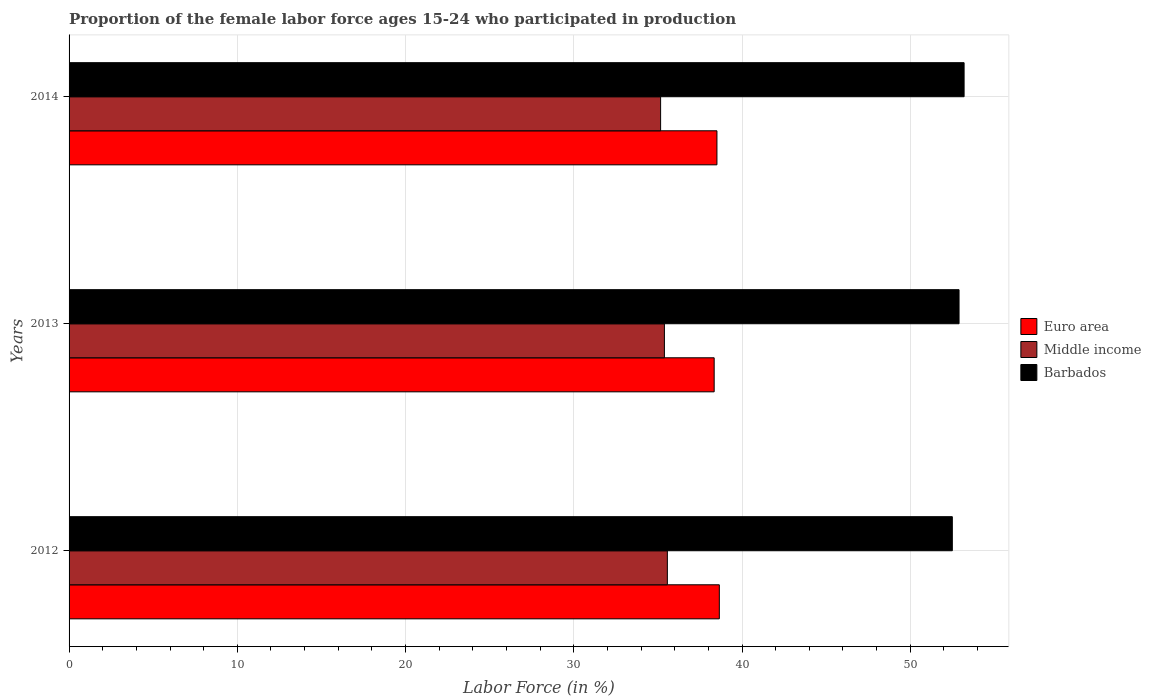How many different coloured bars are there?
Provide a succinct answer. 3. Are the number of bars per tick equal to the number of legend labels?
Offer a very short reply. Yes. Are the number of bars on each tick of the Y-axis equal?
Your response must be concise. Yes. In how many cases, is the number of bars for a given year not equal to the number of legend labels?
Your answer should be compact. 0. What is the proportion of the female labor force who participated in production in Euro area in 2014?
Provide a short and direct response. 38.51. Across all years, what is the maximum proportion of the female labor force who participated in production in Euro area?
Offer a very short reply. 38.65. Across all years, what is the minimum proportion of the female labor force who participated in production in Middle income?
Your answer should be very brief. 35.16. In which year was the proportion of the female labor force who participated in production in Middle income maximum?
Your answer should be very brief. 2012. What is the total proportion of the female labor force who participated in production in Euro area in the graph?
Provide a short and direct response. 115.5. What is the difference between the proportion of the female labor force who participated in production in Barbados in 2013 and that in 2014?
Your answer should be very brief. -0.3. What is the difference between the proportion of the female labor force who participated in production in Middle income in 2014 and the proportion of the female labor force who participated in production in Euro area in 2012?
Your answer should be very brief. -3.49. What is the average proportion of the female labor force who participated in production in Euro area per year?
Keep it short and to the point. 38.5. In the year 2012, what is the difference between the proportion of the female labor force who participated in production in Middle income and proportion of the female labor force who participated in production in Barbados?
Offer a very short reply. -16.94. In how many years, is the proportion of the female labor force who participated in production in Euro area greater than 28 %?
Ensure brevity in your answer.  3. What is the ratio of the proportion of the female labor force who participated in production in Euro area in 2012 to that in 2013?
Your answer should be very brief. 1.01. What is the difference between the highest and the second highest proportion of the female labor force who participated in production in Euro area?
Your answer should be very brief. 0.14. What is the difference between the highest and the lowest proportion of the female labor force who participated in production in Barbados?
Give a very brief answer. 0.7. What does the 3rd bar from the top in 2012 represents?
Give a very brief answer. Euro area. What does the 1st bar from the bottom in 2012 represents?
Keep it short and to the point. Euro area. How many bars are there?
Make the answer very short. 9. Are all the bars in the graph horizontal?
Your response must be concise. Yes. How many years are there in the graph?
Keep it short and to the point. 3. Where does the legend appear in the graph?
Ensure brevity in your answer.  Center right. What is the title of the graph?
Give a very brief answer. Proportion of the female labor force ages 15-24 who participated in production. Does "Gabon" appear as one of the legend labels in the graph?
Your response must be concise. No. What is the label or title of the X-axis?
Offer a very short reply. Labor Force (in %). What is the Labor Force (in %) of Euro area in 2012?
Provide a succinct answer. 38.65. What is the Labor Force (in %) in Middle income in 2012?
Provide a succinct answer. 35.56. What is the Labor Force (in %) in Barbados in 2012?
Ensure brevity in your answer.  52.5. What is the Labor Force (in %) in Euro area in 2013?
Provide a succinct answer. 38.34. What is the Labor Force (in %) in Middle income in 2013?
Your response must be concise. 35.39. What is the Labor Force (in %) of Barbados in 2013?
Keep it short and to the point. 52.9. What is the Labor Force (in %) in Euro area in 2014?
Your answer should be very brief. 38.51. What is the Labor Force (in %) in Middle income in 2014?
Your answer should be very brief. 35.16. What is the Labor Force (in %) of Barbados in 2014?
Make the answer very short. 53.2. Across all years, what is the maximum Labor Force (in %) in Euro area?
Give a very brief answer. 38.65. Across all years, what is the maximum Labor Force (in %) in Middle income?
Ensure brevity in your answer.  35.56. Across all years, what is the maximum Labor Force (in %) of Barbados?
Offer a very short reply. 53.2. Across all years, what is the minimum Labor Force (in %) in Euro area?
Your answer should be compact. 38.34. Across all years, what is the minimum Labor Force (in %) of Middle income?
Offer a terse response. 35.16. Across all years, what is the minimum Labor Force (in %) of Barbados?
Keep it short and to the point. 52.5. What is the total Labor Force (in %) of Euro area in the graph?
Provide a short and direct response. 115.5. What is the total Labor Force (in %) in Middle income in the graph?
Make the answer very short. 106.11. What is the total Labor Force (in %) of Barbados in the graph?
Offer a terse response. 158.6. What is the difference between the Labor Force (in %) of Euro area in 2012 and that in 2013?
Make the answer very short. 0.31. What is the difference between the Labor Force (in %) of Middle income in 2012 and that in 2013?
Provide a succinct answer. 0.18. What is the difference between the Labor Force (in %) of Euro area in 2012 and that in 2014?
Provide a short and direct response. 0.14. What is the difference between the Labor Force (in %) of Middle income in 2012 and that in 2014?
Give a very brief answer. 0.4. What is the difference between the Labor Force (in %) in Barbados in 2012 and that in 2014?
Offer a very short reply. -0.7. What is the difference between the Labor Force (in %) in Euro area in 2013 and that in 2014?
Your response must be concise. -0.16. What is the difference between the Labor Force (in %) in Middle income in 2013 and that in 2014?
Provide a succinct answer. 0.23. What is the difference between the Labor Force (in %) of Euro area in 2012 and the Labor Force (in %) of Middle income in 2013?
Provide a short and direct response. 3.27. What is the difference between the Labor Force (in %) in Euro area in 2012 and the Labor Force (in %) in Barbados in 2013?
Provide a succinct answer. -14.25. What is the difference between the Labor Force (in %) in Middle income in 2012 and the Labor Force (in %) in Barbados in 2013?
Provide a succinct answer. -17.34. What is the difference between the Labor Force (in %) of Euro area in 2012 and the Labor Force (in %) of Middle income in 2014?
Keep it short and to the point. 3.49. What is the difference between the Labor Force (in %) of Euro area in 2012 and the Labor Force (in %) of Barbados in 2014?
Your response must be concise. -14.55. What is the difference between the Labor Force (in %) of Middle income in 2012 and the Labor Force (in %) of Barbados in 2014?
Give a very brief answer. -17.64. What is the difference between the Labor Force (in %) in Euro area in 2013 and the Labor Force (in %) in Middle income in 2014?
Offer a very short reply. 3.18. What is the difference between the Labor Force (in %) in Euro area in 2013 and the Labor Force (in %) in Barbados in 2014?
Make the answer very short. -14.86. What is the difference between the Labor Force (in %) of Middle income in 2013 and the Labor Force (in %) of Barbados in 2014?
Offer a terse response. -17.81. What is the average Labor Force (in %) in Euro area per year?
Give a very brief answer. 38.5. What is the average Labor Force (in %) in Middle income per year?
Your response must be concise. 35.37. What is the average Labor Force (in %) of Barbados per year?
Your response must be concise. 52.87. In the year 2012, what is the difference between the Labor Force (in %) in Euro area and Labor Force (in %) in Middle income?
Your response must be concise. 3.09. In the year 2012, what is the difference between the Labor Force (in %) in Euro area and Labor Force (in %) in Barbados?
Provide a short and direct response. -13.85. In the year 2012, what is the difference between the Labor Force (in %) in Middle income and Labor Force (in %) in Barbados?
Your response must be concise. -16.94. In the year 2013, what is the difference between the Labor Force (in %) in Euro area and Labor Force (in %) in Middle income?
Keep it short and to the point. 2.96. In the year 2013, what is the difference between the Labor Force (in %) of Euro area and Labor Force (in %) of Barbados?
Your answer should be compact. -14.56. In the year 2013, what is the difference between the Labor Force (in %) of Middle income and Labor Force (in %) of Barbados?
Provide a short and direct response. -17.51. In the year 2014, what is the difference between the Labor Force (in %) in Euro area and Labor Force (in %) in Middle income?
Make the answer very short. 3.35. In the year 2014, what is the difference between the Labor Force (in %) in Euro area and Labor Force (in %) in Barbados?
Provide a short and direct response. -14.69. In the year 2014, what is the difference between the Labor Force (in %) in Middle income and Labor Force (in %) in Barbados?
Your answer should be very brief. -18.04. What is the ratio of the Labor Force (in %) in Euro area in 2012 to that in 2013?
Provide a short and direct response. 1.01. What is the ratio of the Labor Force (in %) of Middle income in 2012 to that in 2014?
Give a very brief answer. 1.01. What is the ratio of the Labor Force (in %) in Barbados in 2012 to that in 2014?
Your answer should be compact. 0.99. What is the ratio of the Labor Force (in %) of Euro area in 2013 to that in 2014?
Offer a terse response. 1. What is the ratio of the Labor Force (in %) in Middle income in 2013 to that in 2014?
Keep it short and to the point. 1.01. What is the ratio of the Labor Force (in %) in Barbados in 2013 to that in 2014?
Keep it short and to the point. 0.99. What is the difference between the highest and the second highest Labor Force (in %) in Euro area?
Your answer should be compact. 0.14. What is the difference between the highest and the second highest Labor Force (in %) in Middle income?
Your answer should be very brief. 0.18. What is the difference between the highest and the lowest Labor Force (in %) in Euro area?
Offer a very short reply. 0.31. What is the difference between the highest and the lowest Labor Force (in %) of Middle income?
Provide a short and direct response. 0.4. 